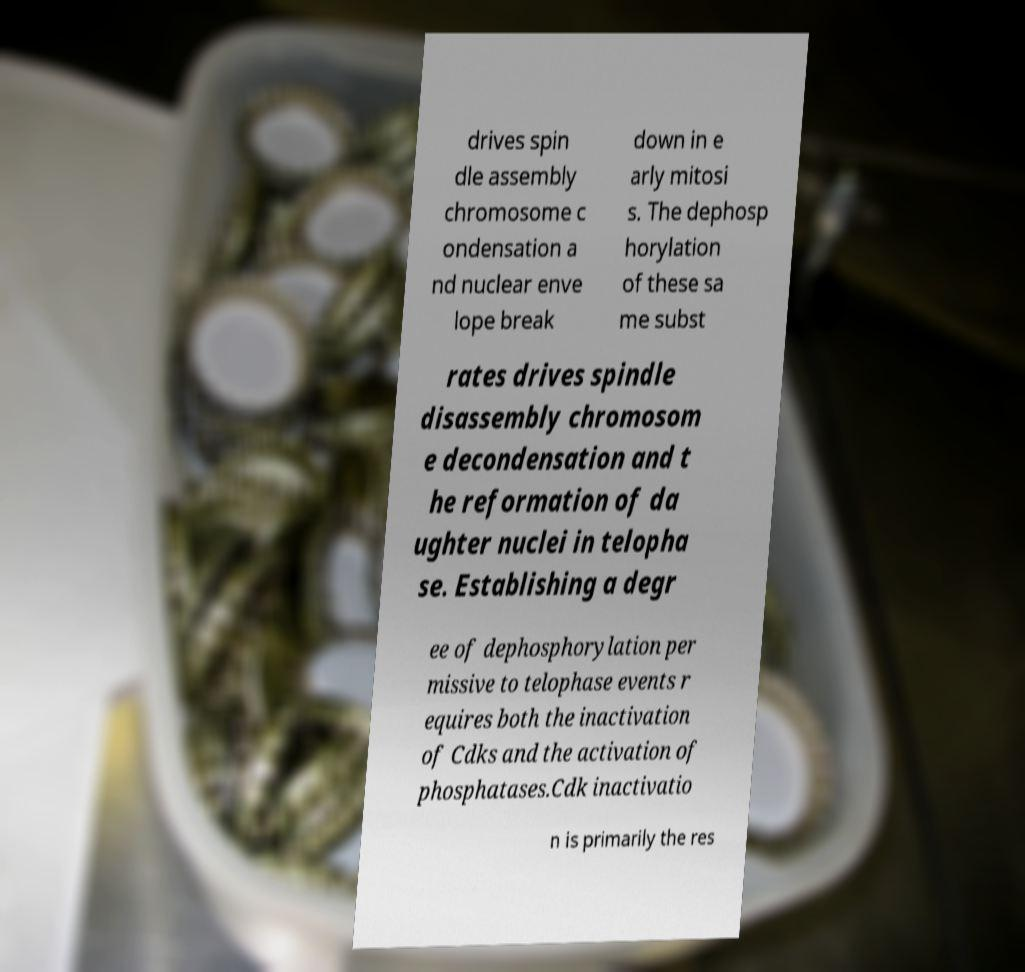Can you accurately transcribe the text from the provided image for me? drives spin dle assembly chromosome c ondensation a nd nuclear enve lope break down in e arly mitosi s. The dephosp horylation of these sa me subst rates drives spindle disassembly chromosom e decondensation and t he reformation of da ughter nuclei in telopha se. Establishing a degr ee of dephosphorylation per missive to telophase events r equires both the inactivation of Cdks and the activation of phosphatases.Cdk inactivatio n is primarily the res 